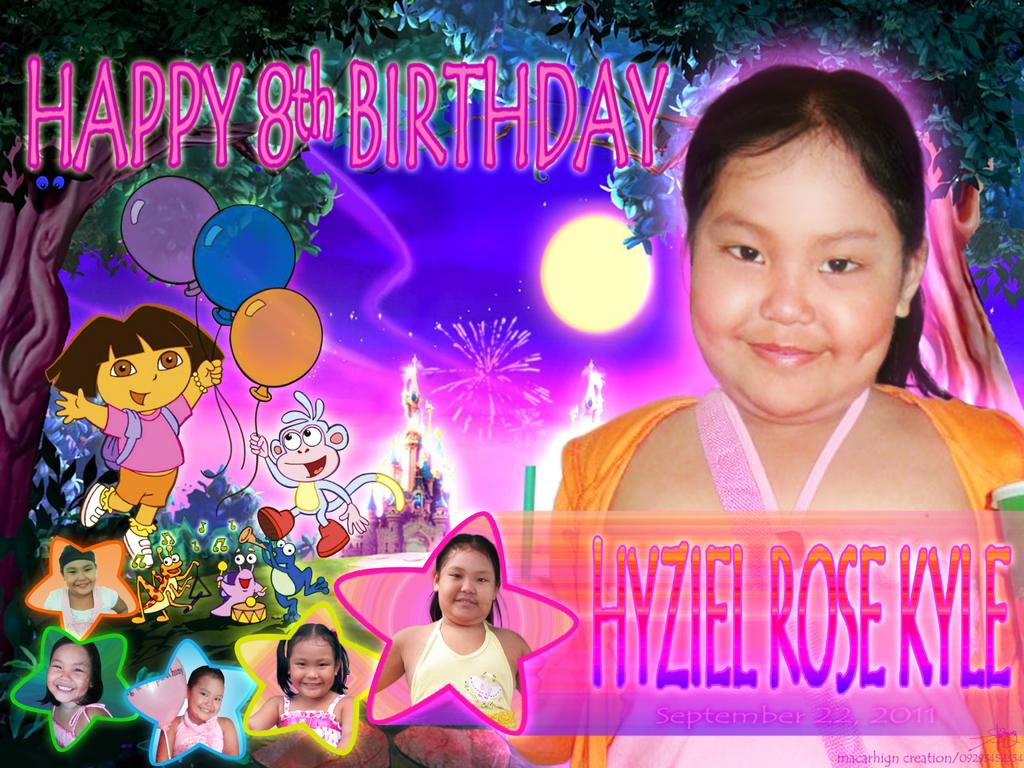What type of card is the image likely to be? The image appears to be a birthday greeting card. Can you describe the girl on the right side of the image? There is a girl on the right side of the image, but no specific details about her appearance are provided. What can be seen on the left side of the image? There are animation images on the left side of the image. How would you describe the overall design of the image? The image resembles a birthday poster. What type of map is visible in the image? There is no map present in the image. How is the bait used in the image? There is no bait present in the image. 